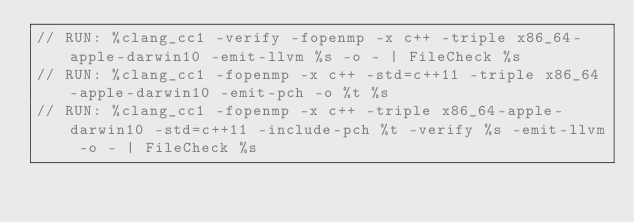Convert code to text. <code><loc_0><loc_0><loc_500><loc_500><_C++_>// RUN: %clang_cc1 -verify -fopenmp -x c++ -triple x86_64-apple-darwin10 -emit-llvm %s -o - | FileCheck %s
// RUN: %clang_cc1 -fopenmp -x c++ -std=c++11 -triple x86_64-apple-darwin10 -emit-pch -o %t %s
// RUN: %clang_cc1 -fopenmp -x c++ -triple x86_64-apple-darwin10 -std=c++11 -include-pch %t -verify %s -emit-llvm -o - | FileCheck %s</code> 